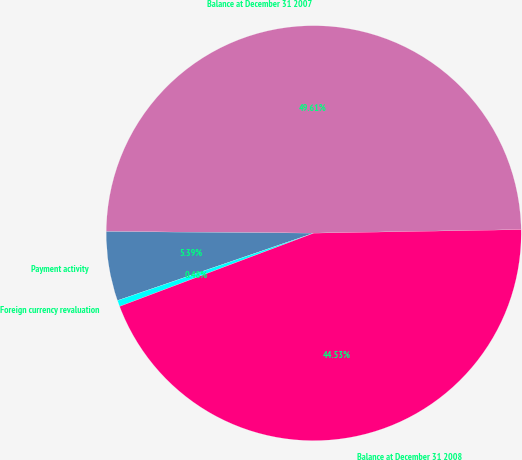Convert chart to OTSL. <chart><loc_0><loc_0><loc_500><loc_500><pie_chart><fcel>Balance at December 31 2007<fcel>Payment activity<fcel>Foreign currency revaluation<fcel>Balance at December 31 2008<nl><fcel>49.61%<fcel>5.39%<fcel>0.48%<fcel>44.53%<nl></chart> 